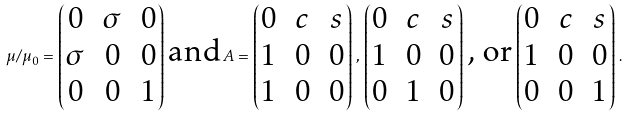Convert formula to latex. <formula><loc_0><loc_0><loc_500><loc_500>\mu / \mu _ { 0 } = \begin{pmatrix} 0 & \sigma & 0 \\ \sigma & 0 & 0 \\ 0 & 0 & 1 \end{pmatrix} \, \text {and} \, A = \begin{pmatrix} 0 & c & s \\ 1 & 0 & 0 \\ 1 & 0 & 0 \end{pmatrix} \, , \, \begin{pmatrix} 0 & c & s \\ 1 & 0 & 0 \\ 0 & 1 & 0 \end{pmatrix} \, \text {, or} \, \begin{pmatrix} 0 & c & s \\ 1 & 0 & 0 \\ 0 & 0 & 1 \end{pmatrix} \, .</formula> 